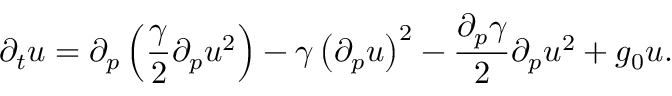Convert formula to latex. <formula><loc_0><loc_0><loc_500><loc_500>\partial _ { t } u = \partial _ { p } \left ( \frac { \gamma } { 2 } \partial _ { p } u ^ { 2 } \right ) - \gamma \left ( \partial _ { p } u \right ) ^ { 2 } - \frac { \partial _ { p } \gamma } { 2 } \partial _ { p } u ^ { 2 } + g _ { 0 } u .</formula> 